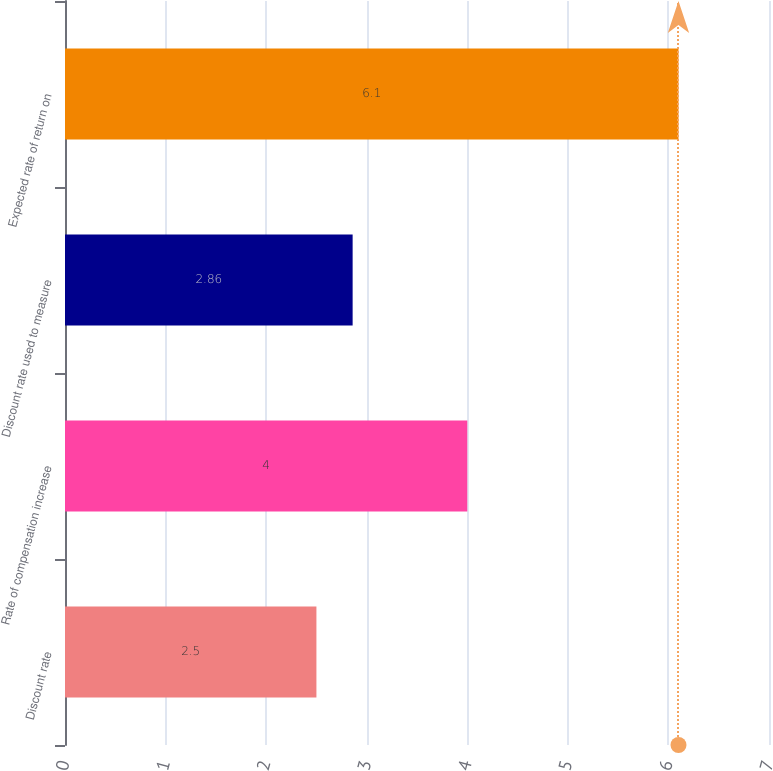<chart> <loc_0><loc_0><loc_500><loc_500><bar_chart><fcel>Discount rate<fcel>Rate of compensation increase<fcel>Discount rate used to measure<fcel>Expected rate of return on<nl><fcel>2.5<fcel>4<fcel>2.86<fcel>6.1<nl></chart> 